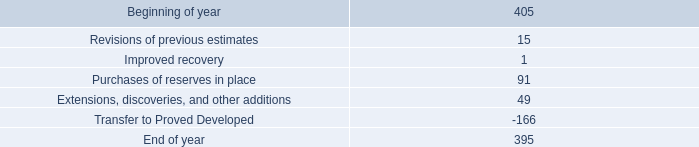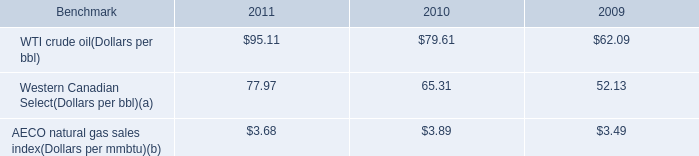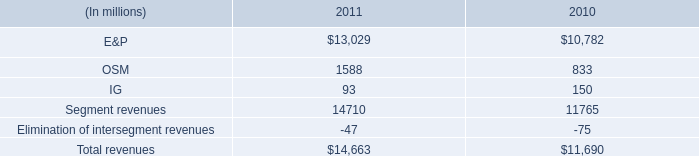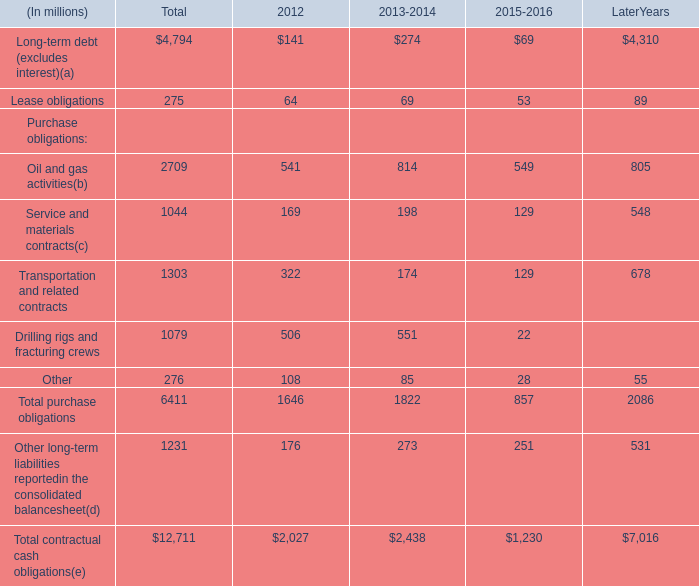by how much did total revenues increase from 2010 to 2011? 
Computations: ((14663 - 11690) / 11690)
Answer: 0.25432. 